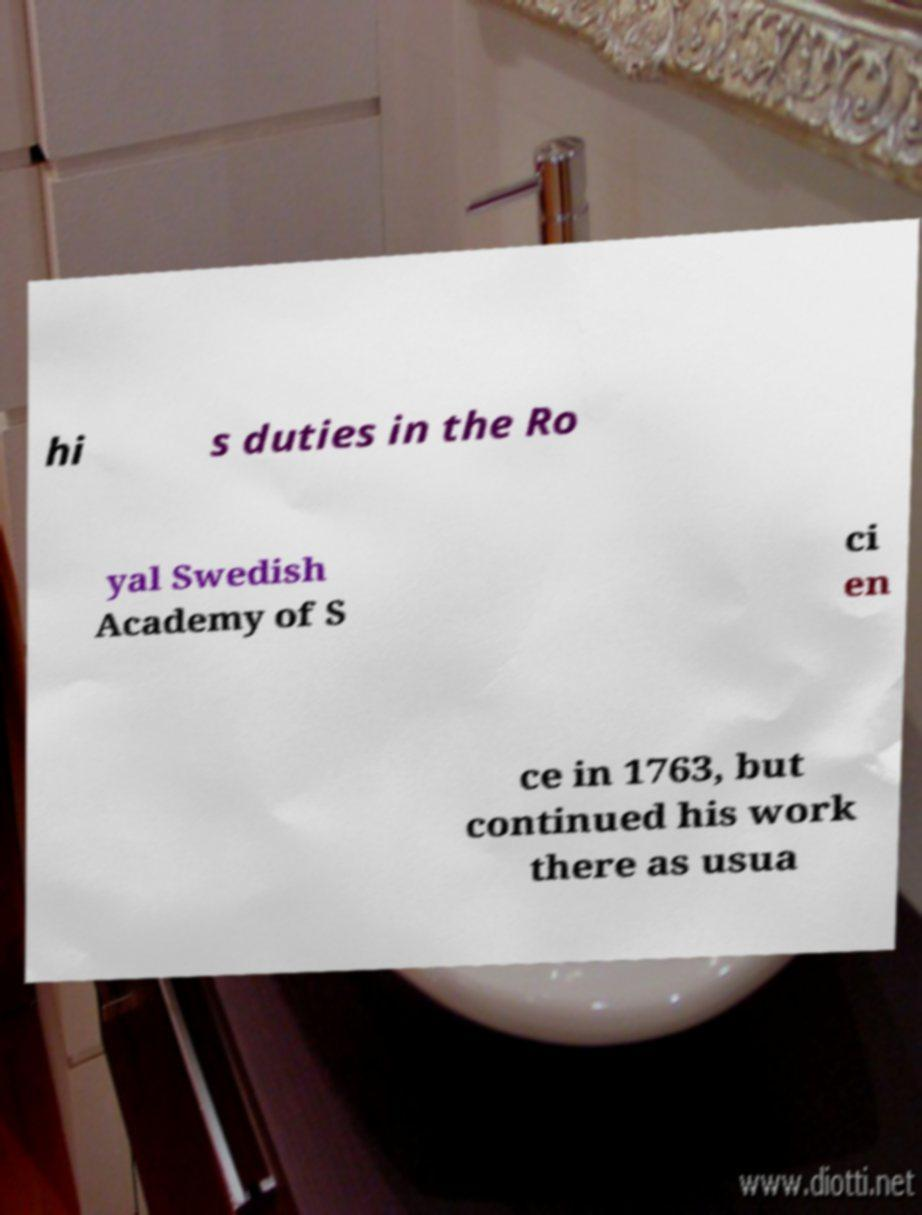Can you accurately transcribe the text from the provided image for me? hi s duties in the Ro yal Swedish Academy of S ci en ce in 1763, but continued his work there as usua 